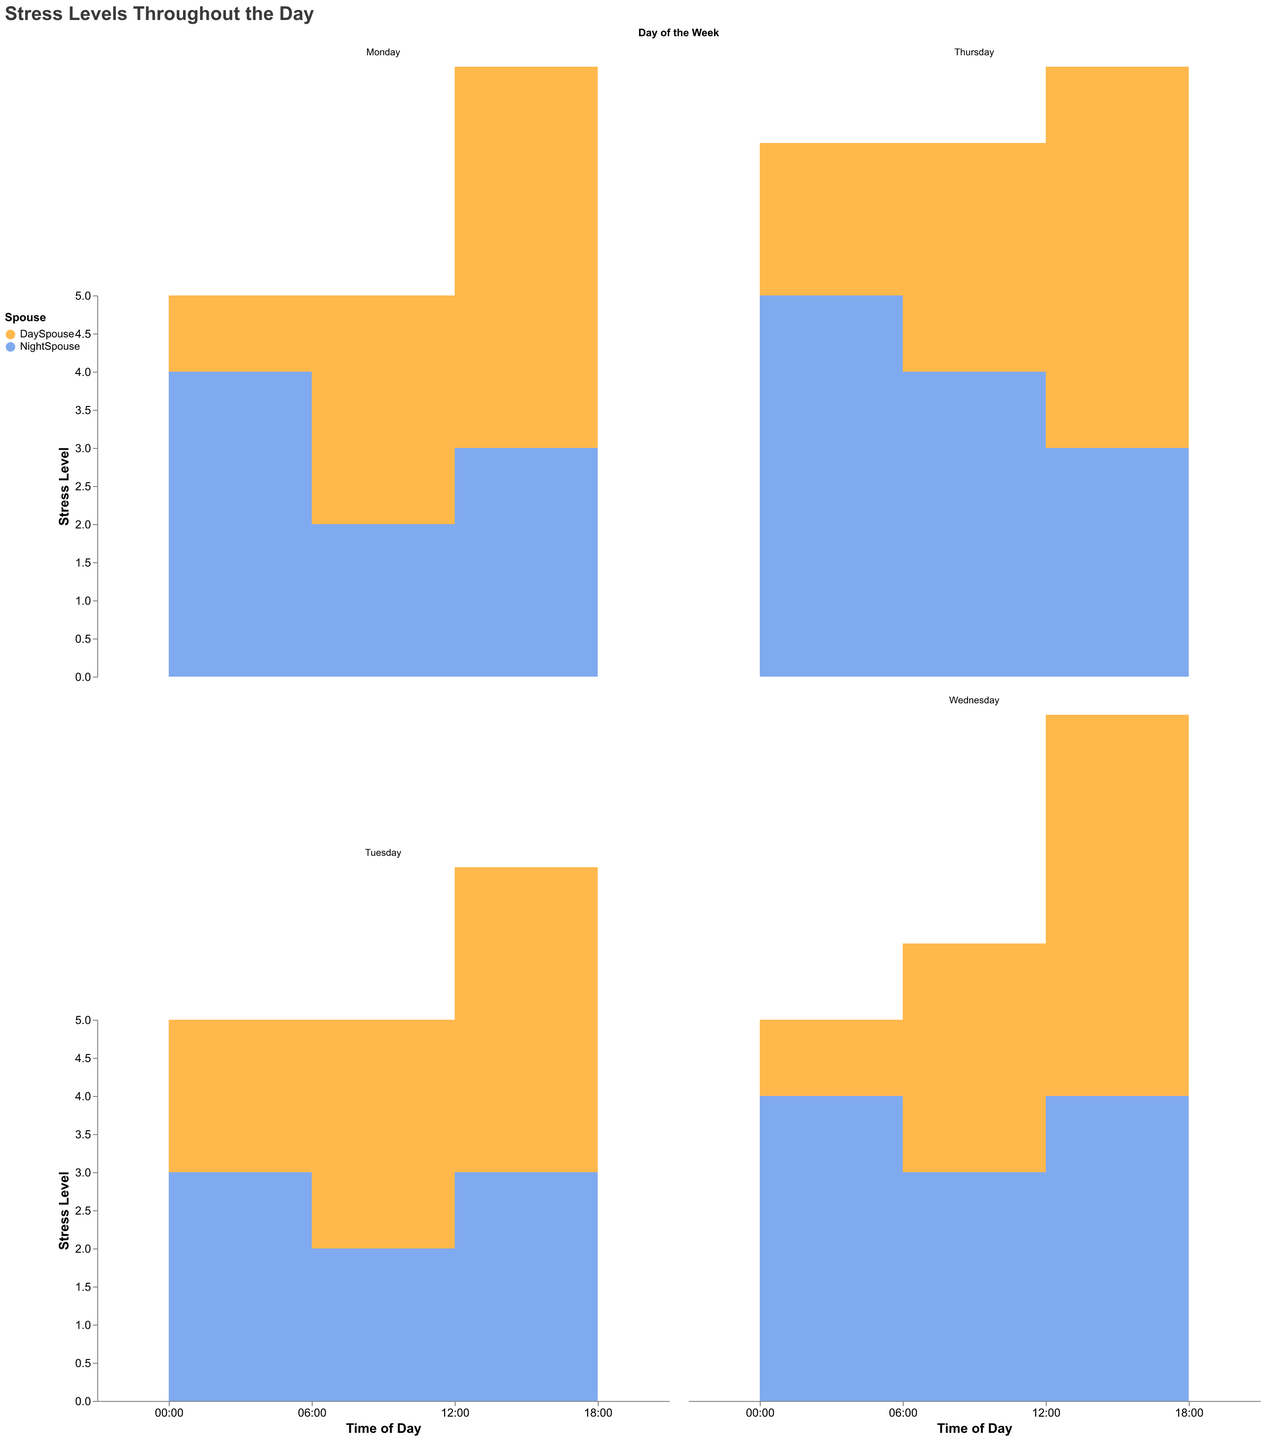What is the title of the chart? The chart's title is usually prominently displayed at the top of the chart. In this case, the JSON code specifies it under the "title" attribute.
Answer: Stress Levels Throughout the Day Which spouse generally has higher stress levels at midnight? By observing the chart, the stress levels for both spouses at midnight (00:00) across different days can be obtained. Comparing them, it is consistently higher for NightSpouse.
Answer: NightSpouse On which day does the NightSpouse experience the highest stress level at noon? We need to compare the stress levels of NightSpouse at 12:00 across all days. The highest value appears on Thursday.
Answer: Thursday At which time of day does DaySpouse have the least stress on Monday? Looking at Monday’s data for DaySpouse, the stress levels at different times are 1 (00:00), 3 (06:00), 5 (12:00), and 4 (18:00). The lowest value is at 00:00.
Answer: 00:00 What is the average stress level for DaySpouse on Tuesday? We need to sum DaySpouse’s stress levels on Tuesday: 2 (00:00), 3 (06:00), 4 (12:00), 5 (18:00). The total is 2 + 3 + 4 + 5 = 14. There are four time points, so the average is 14 / 4 = 3.5.
Answer: 3.5 How does the stress level at 06:00 compare between DaySpouse and NightSpouse on Wednesday? On Wednesday at 06:00, the stress level for DaySpouse is 3 and for NightSpouse is also 3. Both have the same stress level.
Answer: Equal Which day and time show the highest stress level for NightSpouse? For NightSpouse, we need to find the highest stress level at any time on any day. The maximum values are at 00:00 on Thursday (5).
Answer: Thursday at 00:00 What is the difference in stress levels between the two spouses at 12:00 on Monday? At 12:00 on Monday, DaySpouse has a stress level of 5, and NightSpouse has a level of 3. The difference is 5 - 3 = 2.
Answer: 2 Summing up the stress levels at 18:00 for both spouses over Monday and Tuesday, what is the total? Stress levels at 18:00 are DaySpouse: 4 (Monday) + 5 (Tuesday), NightSpouse: 2 (Monday) + 2 (Tuesday). Total is 4 + 5 + 2 + 2 = 13.
Answer: 13 